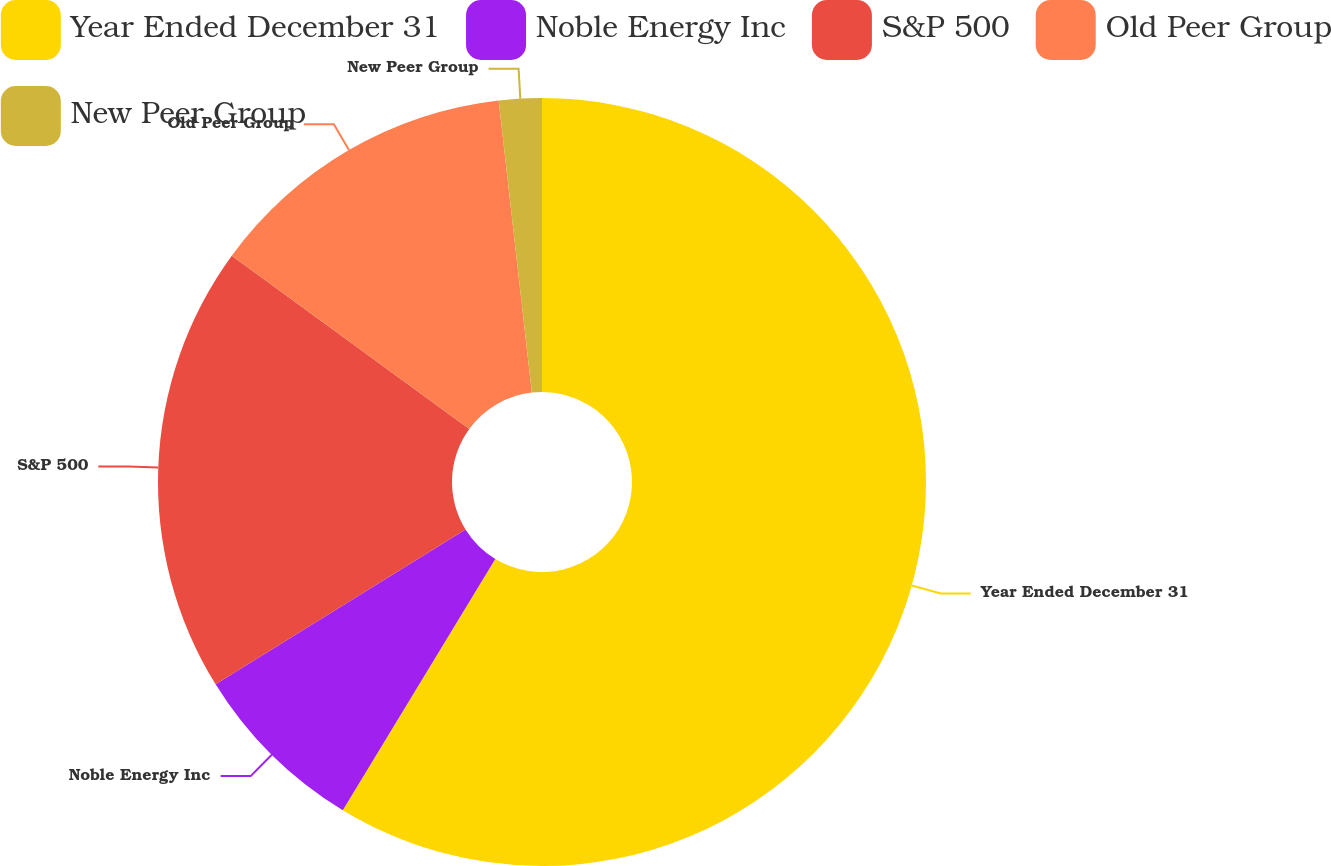<chart> <loc_0><loc_0><loc_500><loc_500><pie_chart><fcel>Year Ended December 31<fcel>Noble Energy Inc<fcel>S&P 500<fcel>Old Peer Group<fcel>New Peer Group<nl><fcel>58.68%<fcel>7.49%<fcel>18.86%<fcel>13.17%<fcel>1.8%<nl></chart> 